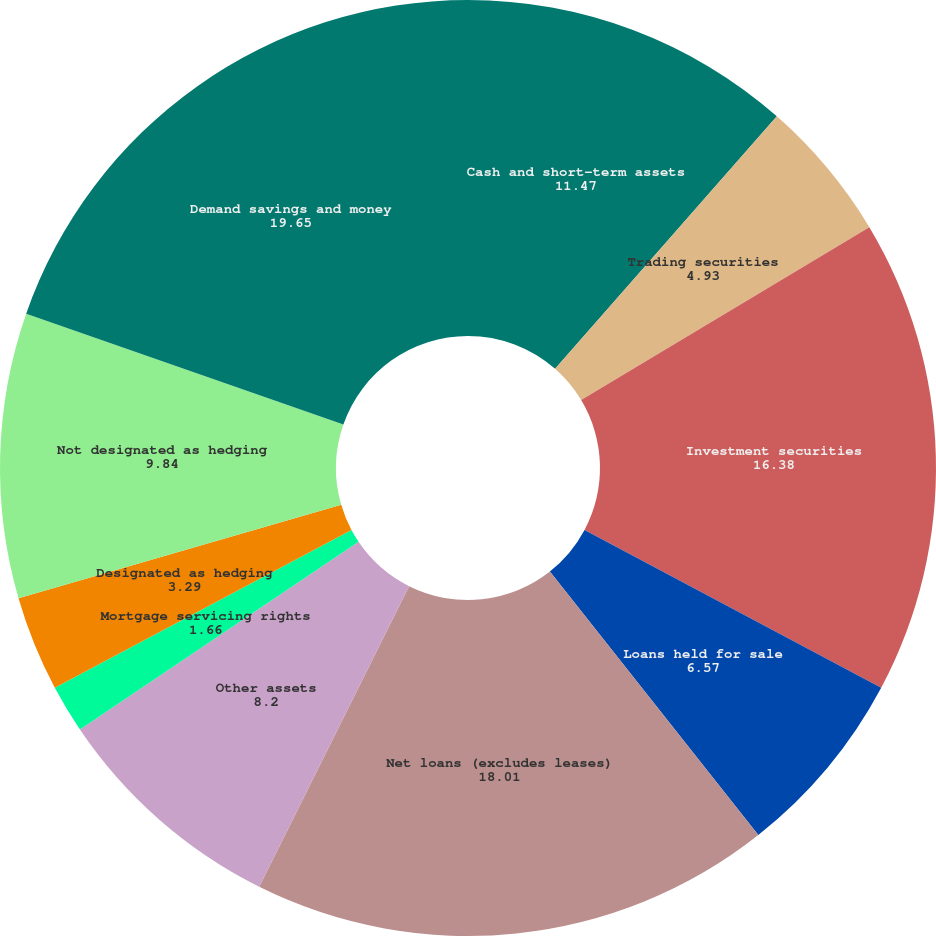Convert chart. <chart><loc_0><loc_0><loc_500><loc_500><pie_chart><fcel>Cash and short-term assets<fcel>Trading securities<fcel>Investment securities<fcel>Loans held for sale<fcel>Net loans (excludes leases)<fcel>Other assets<fcel>Mortgage servicing rights<fcel>Designated as hedging<fcel>Not designated as hedging<fcel>Demand savings and money<nl><fcel>11.47%<fcel>4.93%<fcel>16.38%<fcel>6.57%<fcel>18.01%<fcel>8.2%<fcel>1.66%<fcel>3.29%<fcel>9.84%<fcel>19.65%<nl></chart> 